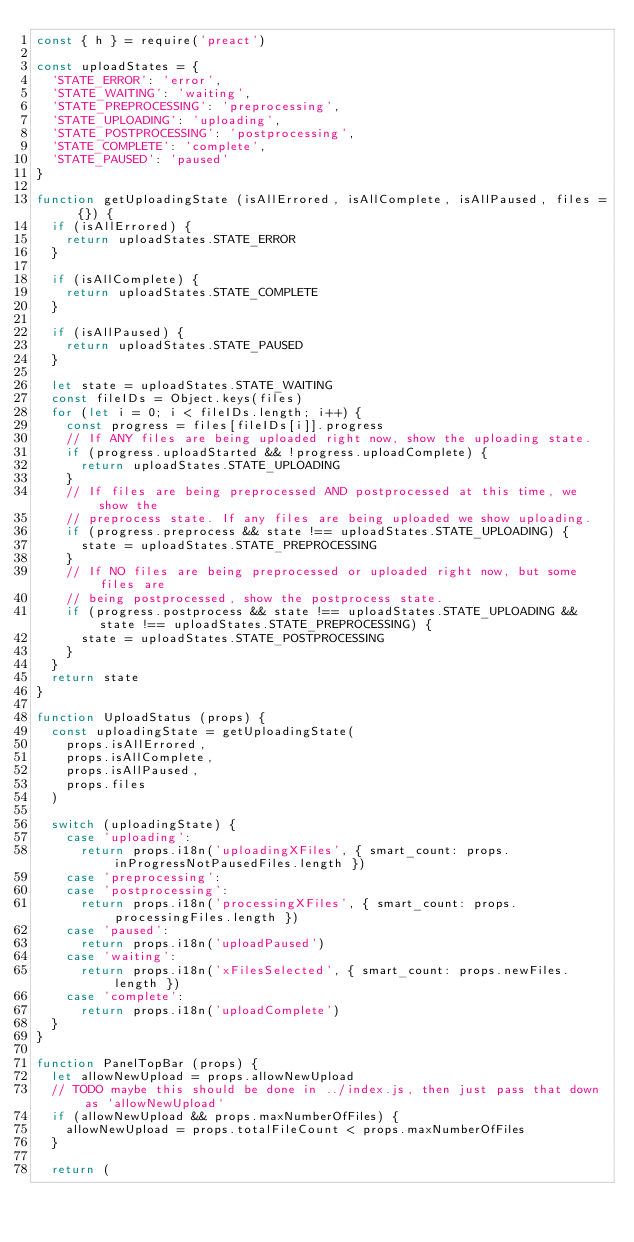<code> <loc_0><loc_0><loc_500><loc_500><_JavaScript_>const { h } = require('preact')

const uploadStates = {
  'STATE_ERROR': 'error',
  'STATE_WAITING': 'waiting',
  'STATE_PREPROCESSING': 'preprocessing',
  'STATE_UPLOADING': 'uploading',
  'STATE_POSTPROCESSING': 'postprocessing',
  'STATE_COMPLETE': 'complete',
  'STATE_PAUSED': 'paused'
}

function getUploadingState (isAllErrored, isAllComplete, isAllPaused, files = {}) {
  if (isAllErrored) {
    return uploadStates.STATE_ERROR
  }

  if (isAllComplete) {
    return uploadStates.STATE_COMPLETE
  }

  if (isAllPaused) {
    return uploadStates.STATE_PAUSED
  }

  let state = uploadStates.STATE_WAITING
  const fileIDs = Object.keys(files)
  for (let i = 0; i < fileIDs.length; i++) {
    const progress = files[fileIDs[i]].progress
    // If ANY files are being uploaded right now, show the uploading state.
    if (progress.uploadStarted && !progress.uploadComplete) {
      return uploadStates.STATE_UPLOADING
    }
    // If files are being preprocessed AND postprocessed at this time, we show the
    // preprocess state. If any files are being uploaded we show uploading.
    if (progress.preprocess && state !== uploadStates.STATE_UPLOADING) {
      state = uploadStates.STATE_PREPROCESSING
    }
    // If NO files are being preprocessed or uploaded right now, but some files are
    // being postprocessed, show the postprocess state.
    if (progress.postprocess && state !== uploadStates.STATE_UPLOADING && state !== uploadStates.STATE_PREPROCESSING) {
      state = uploadStates.STATE_POSTPROCESSING
    }
  }
  return state
}

function UploadStatus (props) {
  const uploadingState = getUploadingState(
    props.isAllErrored,
    props.isAllComplete,
    props.isAllPaused,
    props.files
  )

  switch (uploadingState) {
    case 'uploading':
      return props.i18n('uploadingXFiles', { smart_count: props.inProgressNotPausedFiles.length })
    case 'preprocessing':
    case 'postprocessing':
      return props.i18n('processingXFiles', { smart_count: props.processingFiles.length })
    case 'paused':
      return props.i18n('uploadPaused')
    case 'waiting':
      return props.i18n('xFilesSelected', { smart_count: props.newFiles.length })
    case 'complete':
      return props.i18n('uploadComplete')
  }
}

function PanelTopBar (props) {
  let allowNewUpload = props.allowNewUpload
  // TODO maybe this should be done in ../index.js, then just pass that down as `allowNewUpload`
  if (allowNewUpload && props.maxNumberOfFiles) {
    allowNewUpload = props.totalFileCount < props.maxNumberOfFiles
  }

  return (</code> 